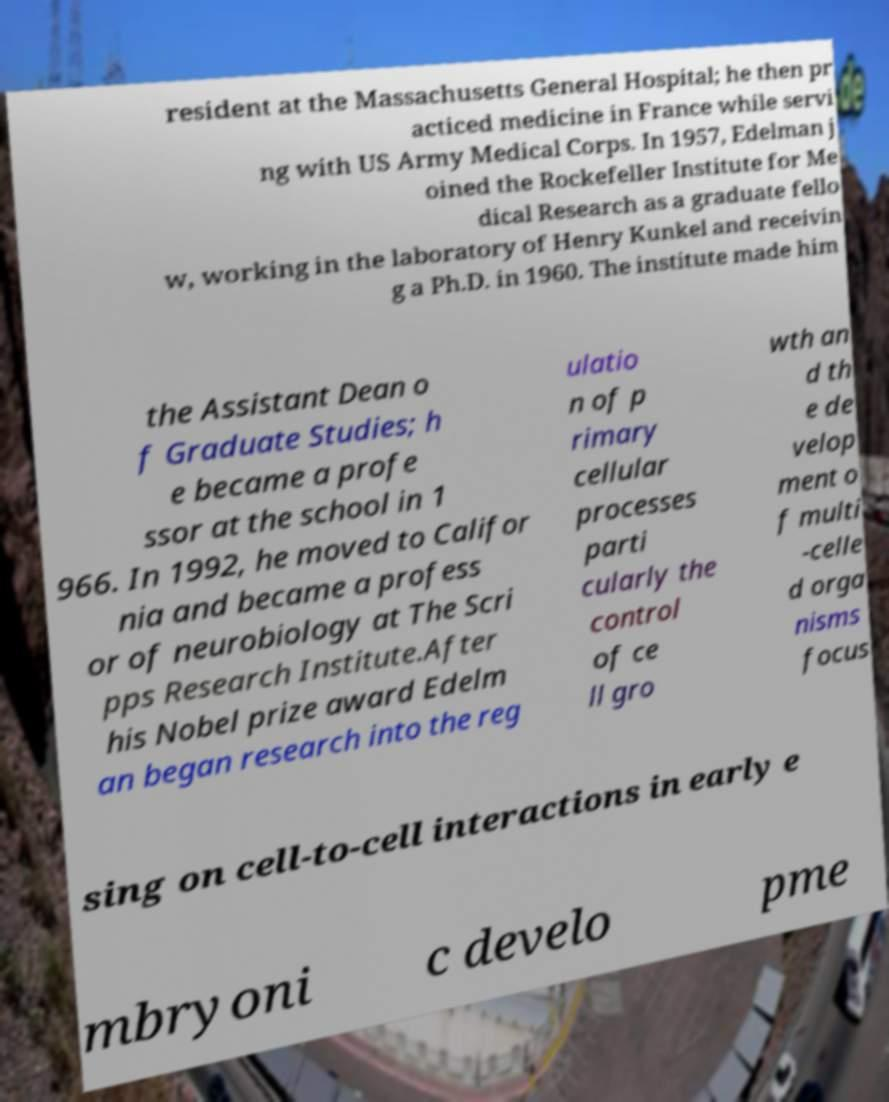There's text embedded in this image that I need extracted. Can you transcribe it verbatim? resident at the Massachusetts General Hospital; he then pr acticed medicine in France while servi ng with US Army Medical Corps. In 1957, Edelman j oined the Rockefeller Institute for Me dical Research as a graduate fello w, working in the laboratory of Henry Kunkel and receivin g a Ph.D. in 1960. The institute made him the Assistant Dean o f Graduate Studies; h e became a profe ssor at the school in 1 966. In 1992, he moved to Califor nia and became a profess or of neurobiology at The Scri pps Research Institute.After his Nobel prize award Edelm an began research into the reg ulatio n of p rimary cellular processes parti cularly the control of ce ll gro wth an d th e de velop ment o f multi -celle d orga nisms focus sing on cell-to-cell interactions in early e mbryoni c develo pme 